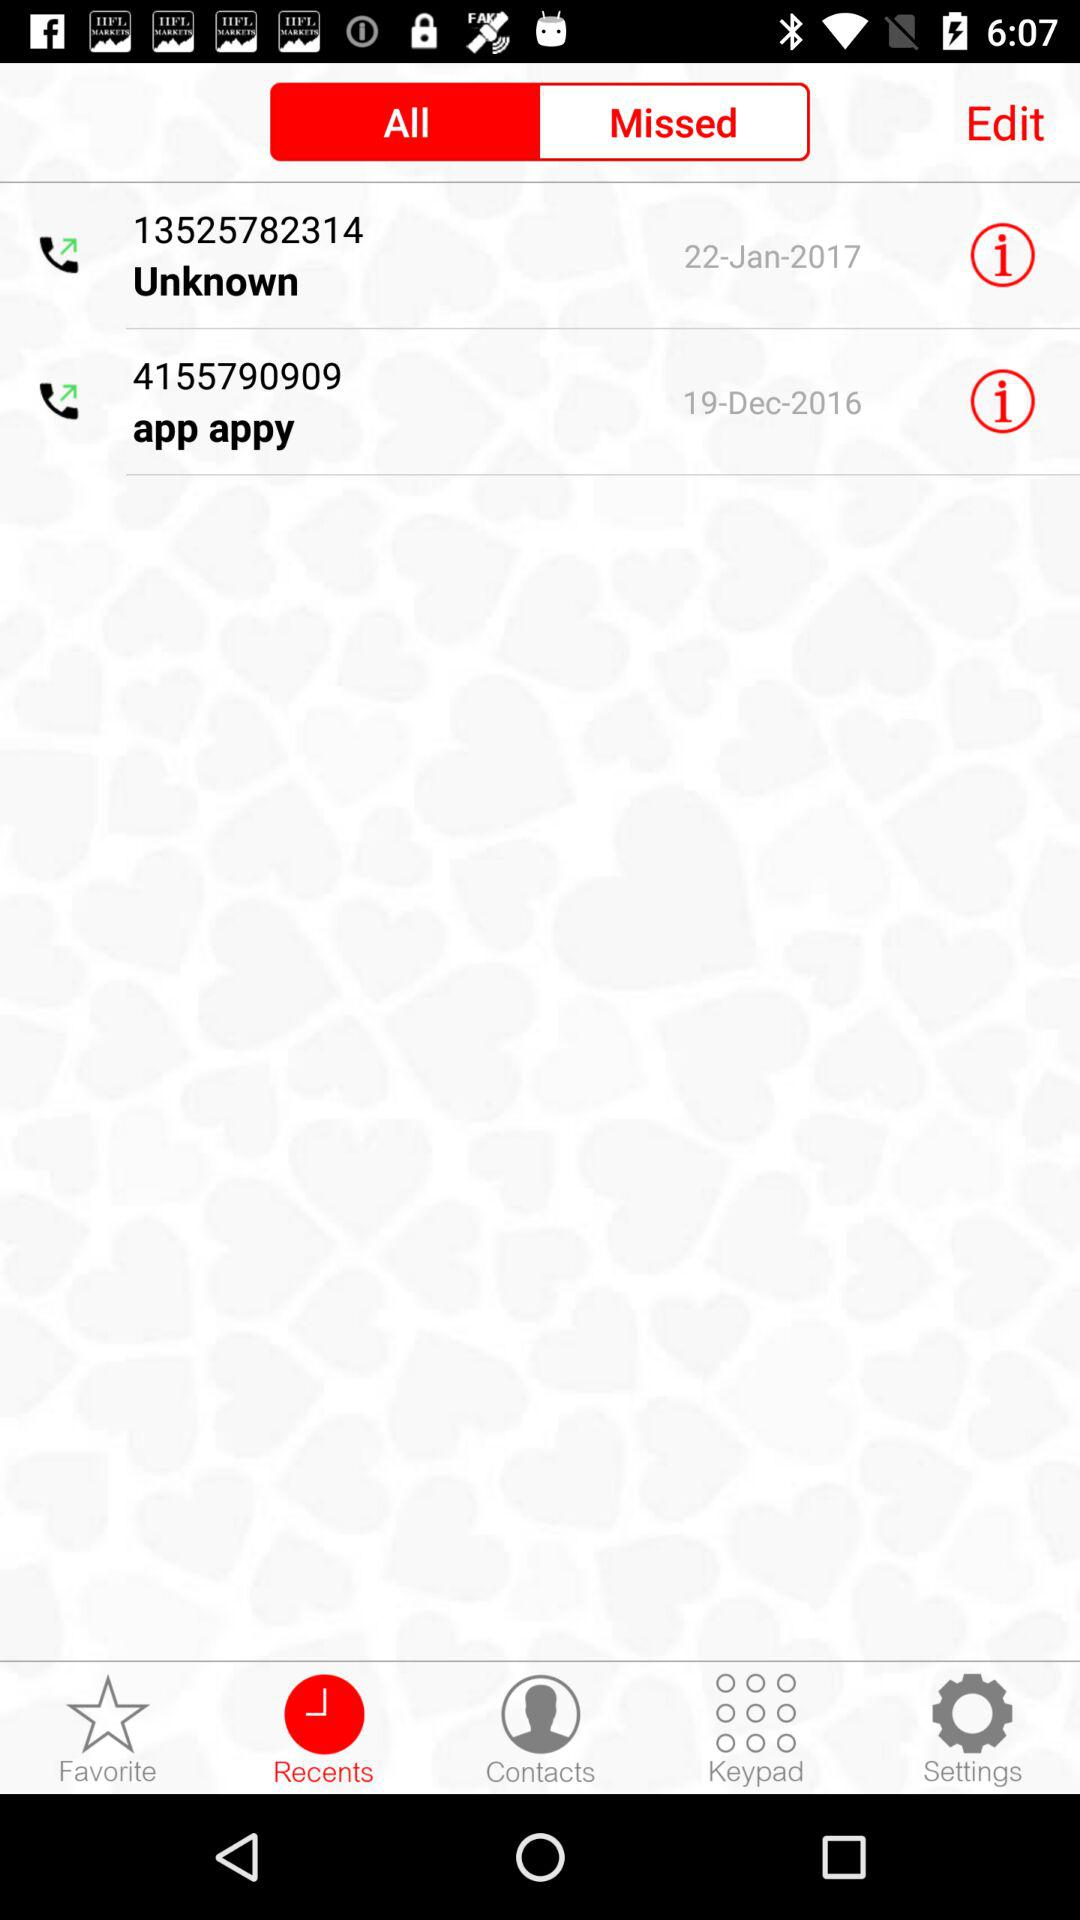What is the contact number for App Appy? The contact number for App Appy is 4155790909. 